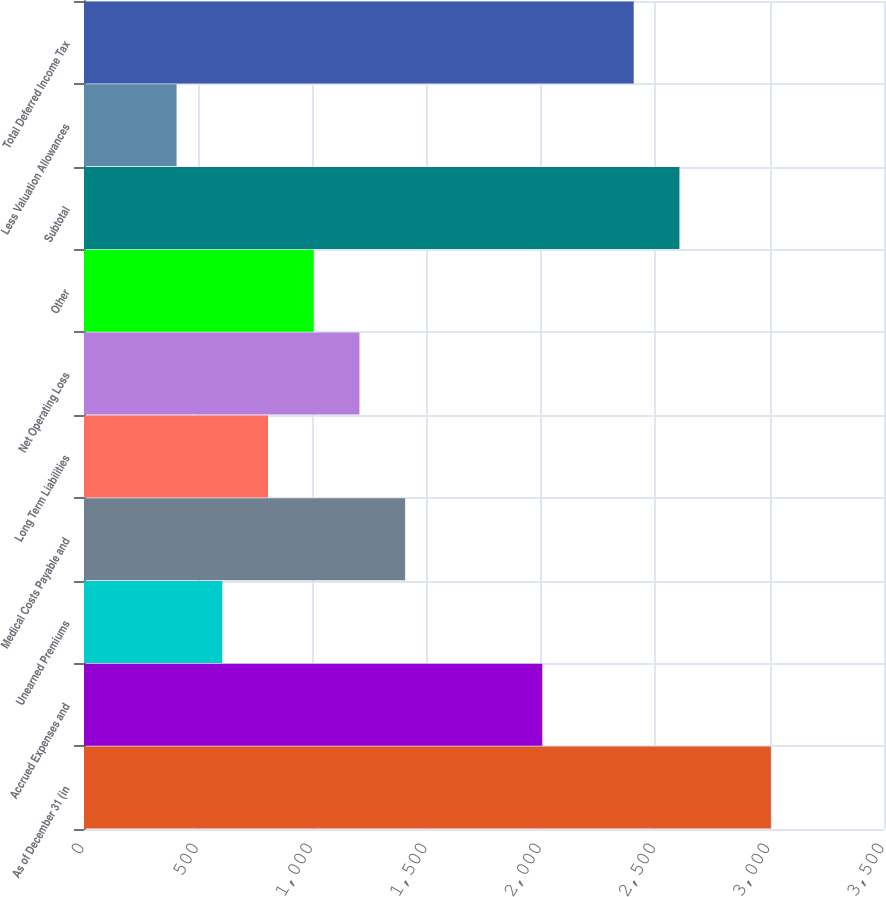<chart> <loc_0><loc_0><loc_500><loc_500><bar_chart><fcel>As of December 31 (in<fcel>Accrued Expenses and<fcel>Unearned Premiums<fcel>Medical Costs Payable and<fcel>Long Term Liabilities<fcel>Net Operating Loss<fcel>Other<fcel>Subtotal<fcel>Less Valuation Allowances<fcel>Total Deferred Income Tax<nl><fcel>3005<fcel>2005<fcel>605<fcel>1405<fcel>805<fcel>1205<fcel>1005<fcel>2605<fcel>405<fcel>2405<nl></chart> 